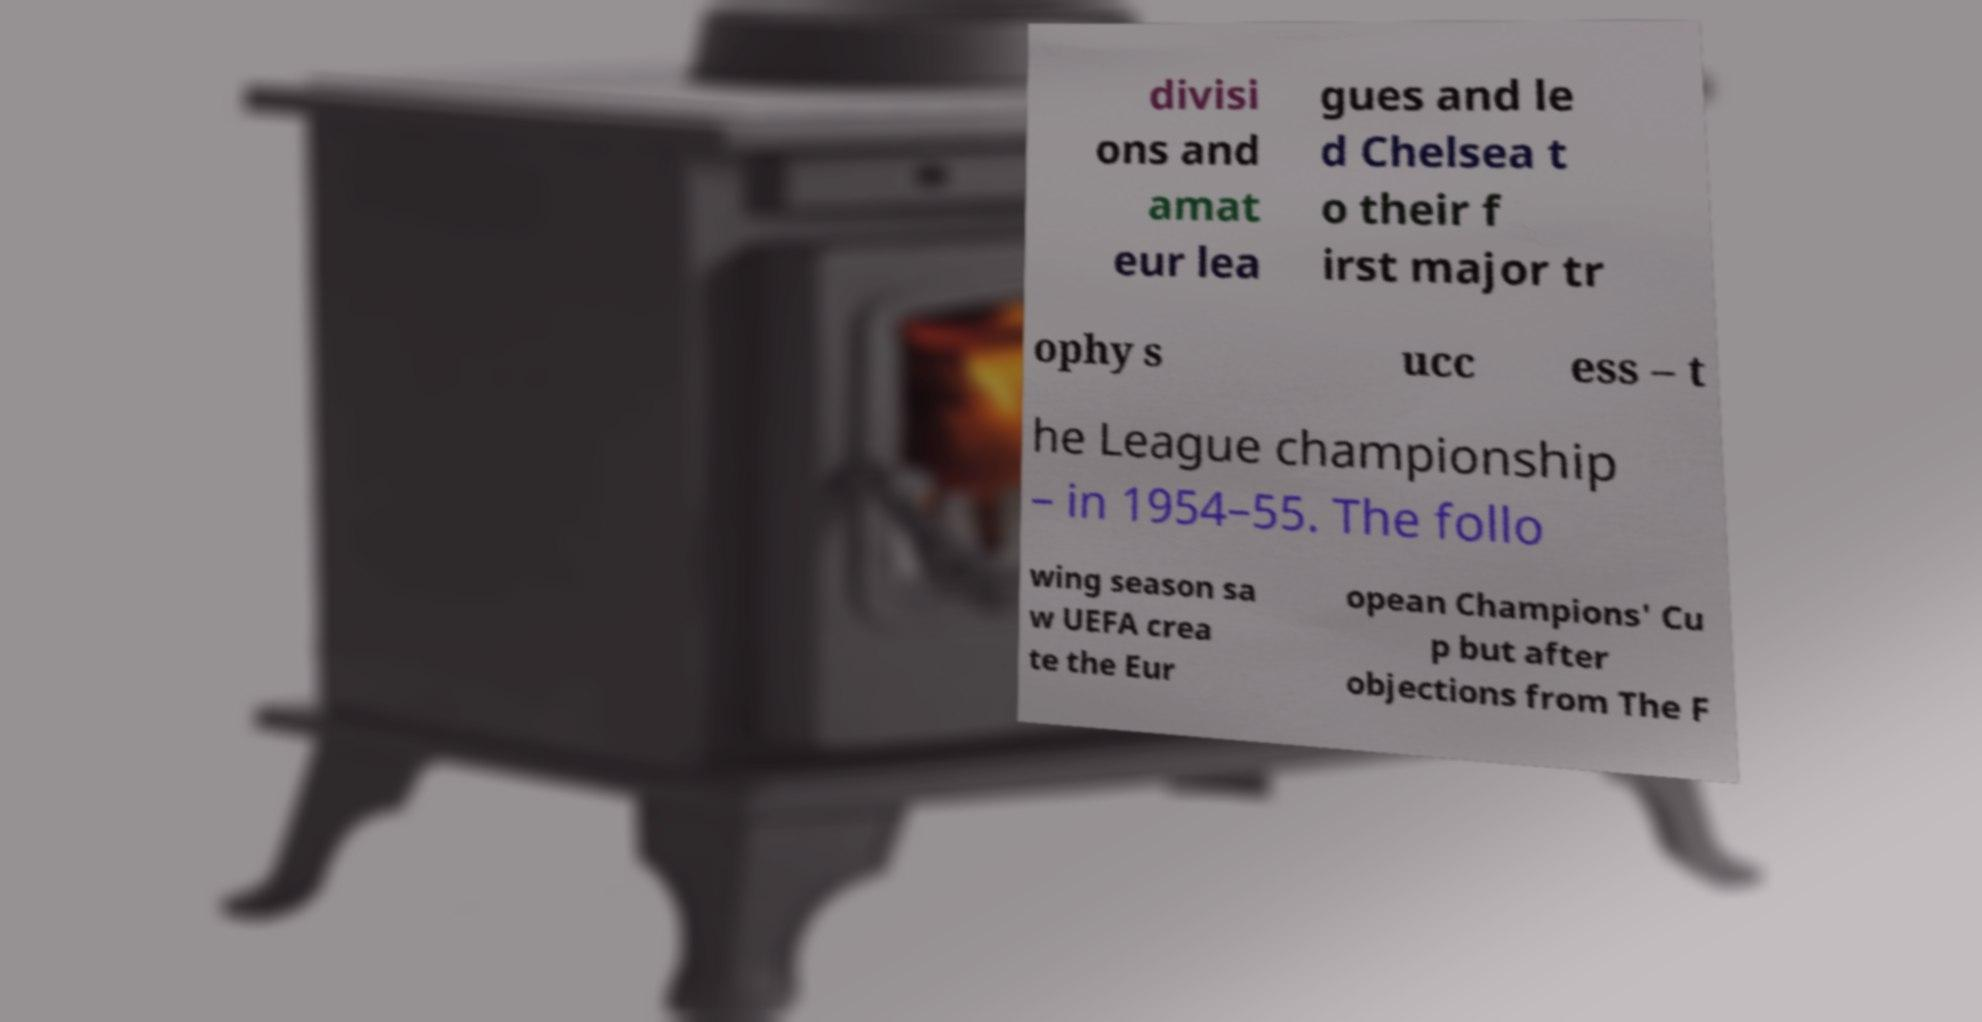There's text embedded in this image that I need extracted. Can you transcribe it verbatim? divisi ons and amat eur lea gues and le d Chelsea t o their f irst major tr ophy s ucc ess – t he League championship – in 1954–55. The follo wing season sa w UEFA crea te the Eur opean Champions' Cu p but after objections from The F 